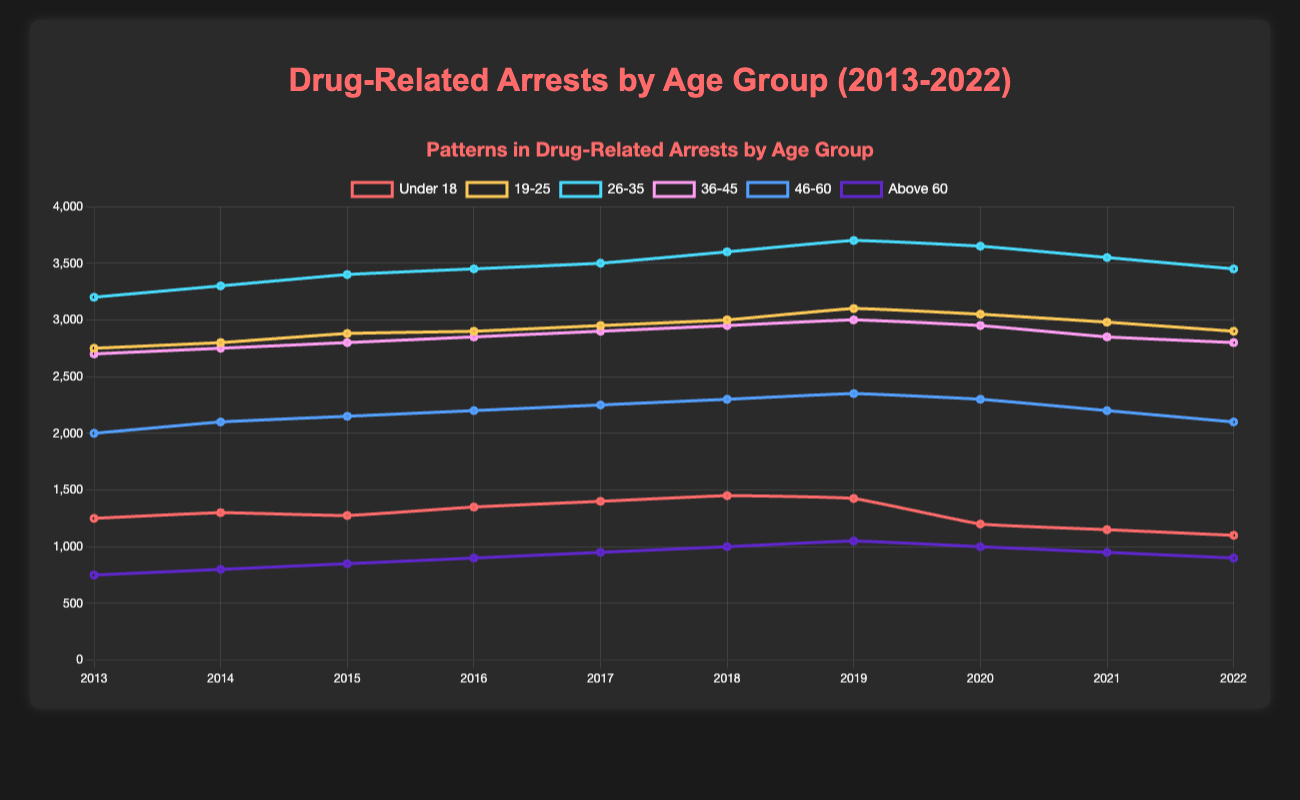What age group saw the sharpest decline in drug-related arrests from 2019 to 2022? To find this, we look at the difference in arrests from 2019 to 2022 for each age group. "Under 18" dropped from 1425 to 1100, a decline of 325 arrests. "19-25" dropped from 3100 to 2900, a difference of 200. "26-35" dropped from 3700 to 3450, a difference of 250. "36-45" dropped from 3000 to 2800, a difference of 200. "46-60" dropped from 2350 to 2100, a difference of 250. "Above 60" dropped from 1050 to 900, a difference of 150. The "Under 18" group had the largest decline of 325.
Answer: Under 18 Which age group had the highest peak in drug-related arrests during the decade? To determine this, identify the highest value across all age groups from 2013 to 2022. The peak value is in the "26-35" group in 2019 at 3700 arrests.
Answer: 26-35 What was the average number of arrests for the age group "Above 60" during the period 2013-2022? The values for "Above 60" are 750, 800, 850, 900, 950, 1000, 1050, 1000, 950, 900. Summing these gives 8150, and dividing by 10 (years) results in an average of 815.
Answer: 815 Between which consecutive years did the age group "19-25" see the biggest increase in the number of arrests? Calculate the difference for each consecutive year for the "19-25" group. The biggest increase (3100 - 3000) =100 front 2018 to 2019.
Answer: 2018-2019 Which age group had the most consistent number of arrests over the decade? Consistency can be assessed by examining the visual smoothness and minimal fluctuations in the line. The "46-60" group's line shows minimal variation, hovering close to 2250 arrests with smaller fluctuations.
Answer: 46-60 How did the number of arrests for the age group "Under 18" differ from 2013 to 2022? The value declined from 1250 in 2013 to 1100 in 2022. The difference is a decrease of 150 arrests (1250 - 1100).
Answer: Decreased by 150 Which age group showed a notable decline in arrests in 2020? By comparing 2019 to 2020, the "Under 18" group showed a significant decline from 1425 to 1200, a decrease of 225 arrests.
Answer: Under 18 In which year did the age group "36-45" see the highest number of arrests? Reviewing the values for the "36-45" group indicates the highest number was 3000 in 2019.
Answer: 2019 What was the sum of drug-related arrests in 2017 across all age groups? Summing the 2017 values: 1400 (Under 18) + 2950 (19-25) + 3500 (26-35) + 2900 (36-45) + 2250 (46-60) + 950 (Above 60) = 13950.
Answer: 13950 